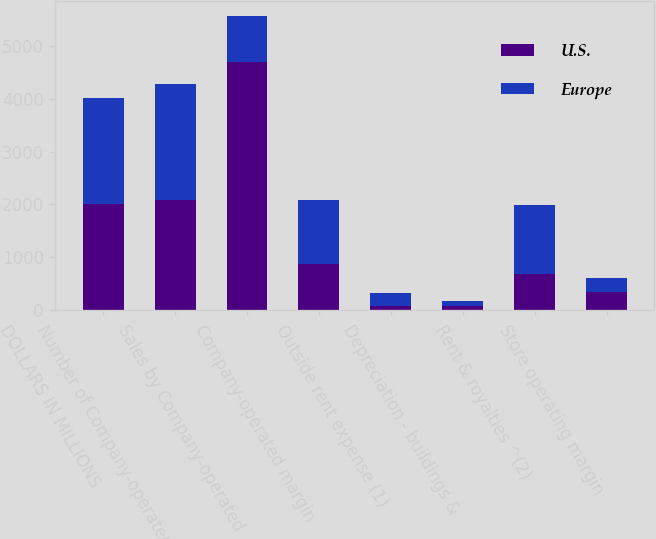Convert chart. <chart><loc_0><loc_0><loc_500><loc_500><stacked_bar_chart><ecel><fcel>DOLLARS IN MILLIONS<fcel>Number of Company-operated<fcel>Sales by Company-operated<fcel>Company-operated margin<fcel>Outside rent expense (1)<fcel>Depreciation - buildings &<fcel>Rent & royalties ^(2)<fcel>Store operating margin<nl><fcel>U.S.<fcel>2007<fcel>2090<fcel>4682<fcel>876<fcel>82<fcel>78<fcel>691<fcel>345<nl><fcel>Europe<fcel>2007<fcel>2177<fcel>876<fcel>1205<fcel>248<fcel>107<fcel>1294<fcel>266<nl></chart> 